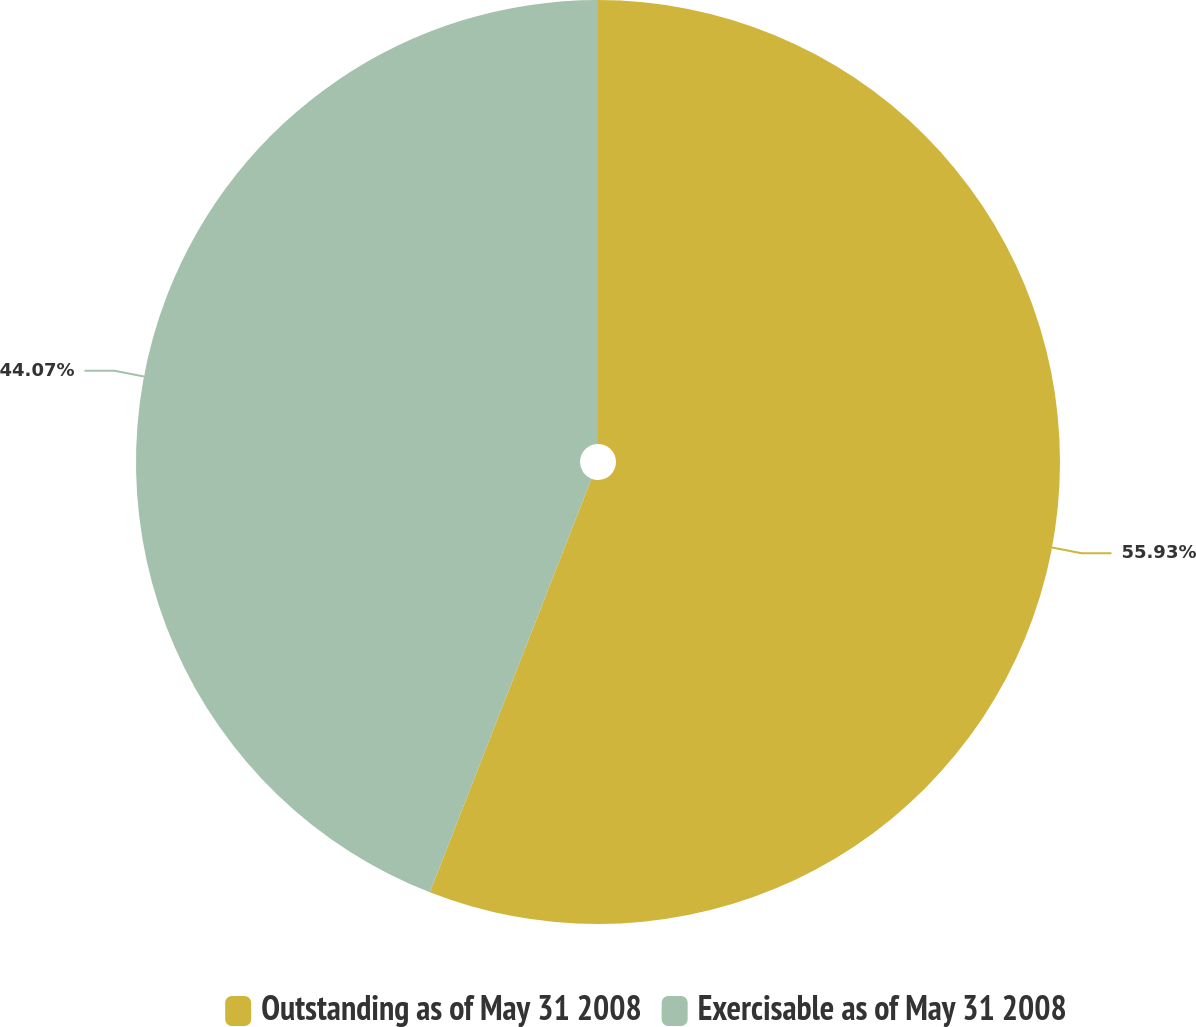Convert chart to OTSL. <chart><loc_0><loc_0><loc_500><loc_500><pie_chart><fcel>Outstanding as of May 31 2008<fcel>Exercisable as of May 31 2008<nl><fcel>55.93%<fcel>44.07%<nl></chart> 